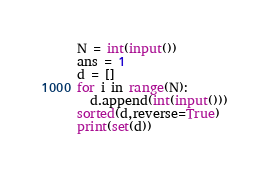<code> <loc_0><loc_0><loc_500><loc_500><_Python_>N = int(input())
ans = 1
d = []
for i in range(N):
  d.append(int(input()))
sorted(d,reverse=True)
print(set(d))
</code> 